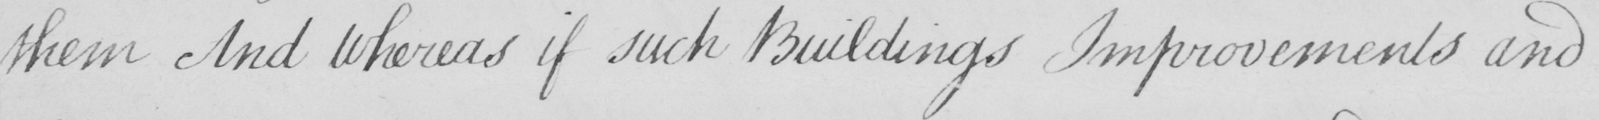Can you read and transcribe this handwriting? them And Whereas if such Buildings Improvements and 